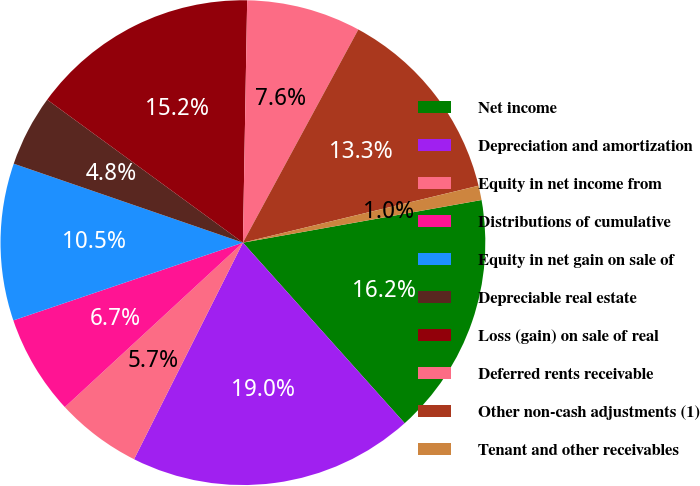Convert chart. <chart><loc_0><loc_0><loc_500><loc_500><pie_chart><fcel>Net income<fcel>Depreciation and amortization<fcel>Equity in net income from<fcel>Distributions of cumulative<fcel>Equity in net gain on sale of<fcel>Depreciable real estate<fcel>Loss (gain) on sale of real<fcel>Deferred rents receivable<fcel>Other non-cash adjustments (1)<fcel>Tenant and other receivables<nl><fcel>16.19%<fcel>19.04%<fcel>5.72%<fcel>6.67%<fcel>10.48%<fcel>4.76%<fcel>15.24%<fcel>7.62%<fcel>13.33%<fcel>0.96%<nl></chart> 